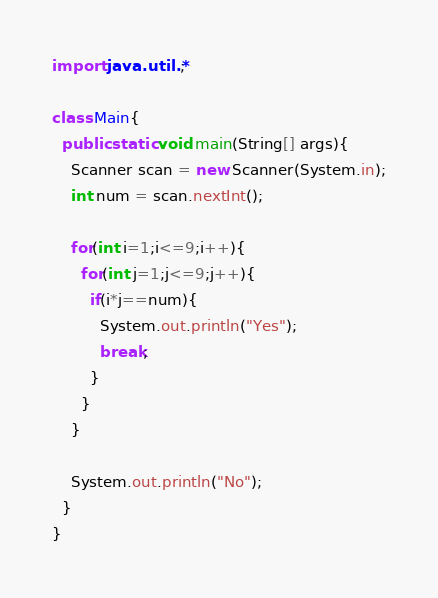Convert code to text. <code><loc_0><loc_0><loc_500><loc_500><_Java_>import java.util.*;

class Main{
  public static void main(String[] args){
    Scanner scan = new Scanner(System.in);
    int num = scan.nextInt();
    
    for(int i=1;i<=9;i++){
      for(int j=1;j<=9;j++){
        if(i*j==num){
          System.out.println("Yes");
          break;
        }
      }
    }
    
    System.out.println("No");
  }
}
</code> 